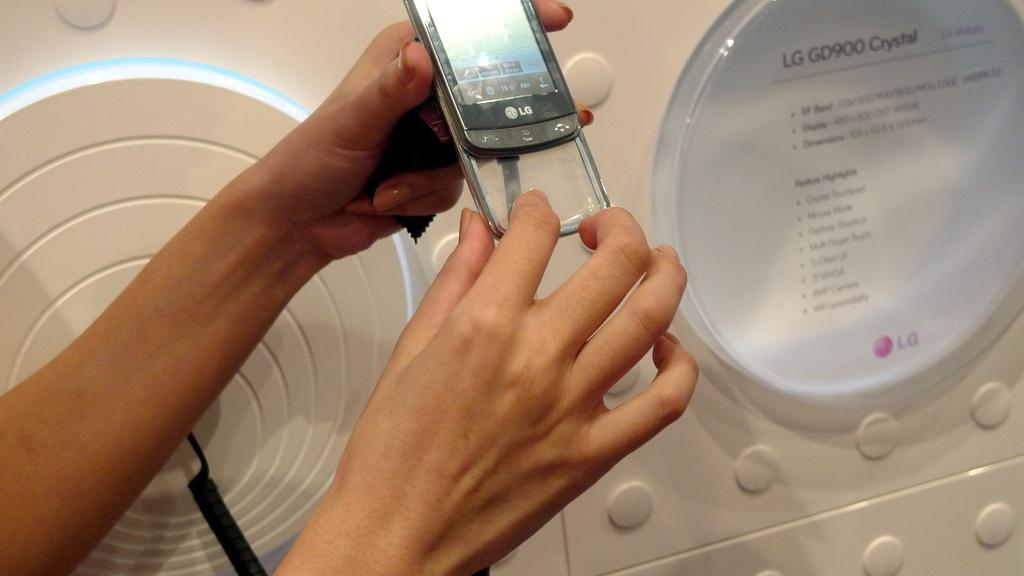<image>
Relay a brief, clear account of the picture shown. a silver phone with a women holding this item 